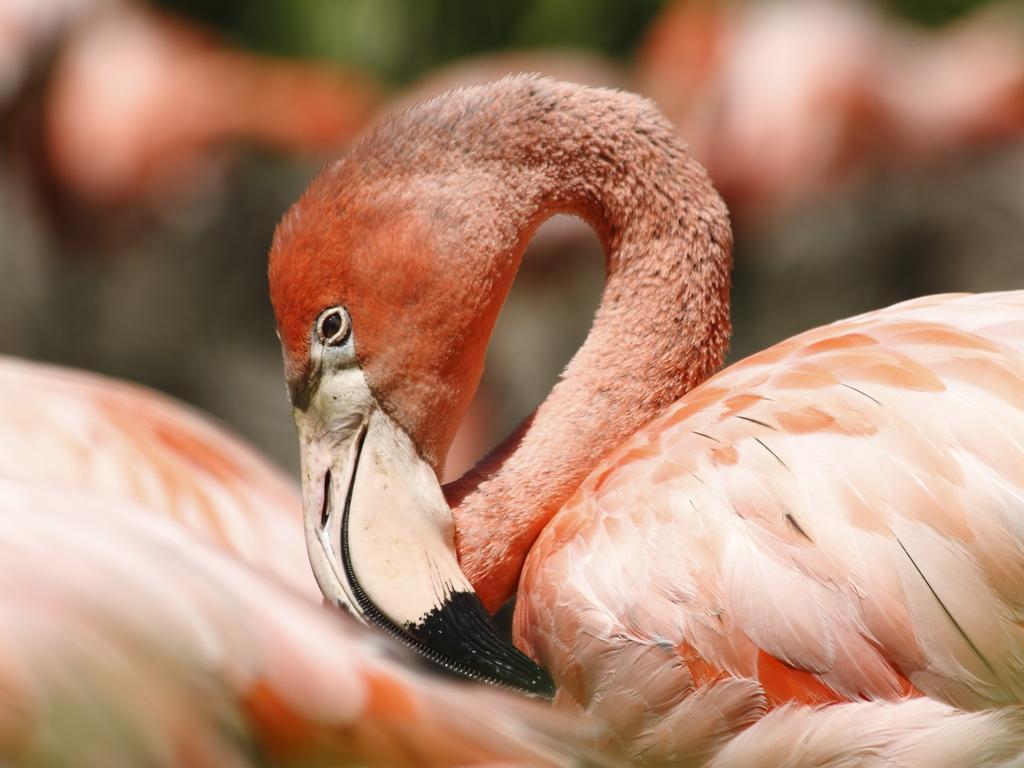In one or two sentences, can you explain what this image depicts? There is a bird as we can see in the middle of this image, and the background is blurred. 